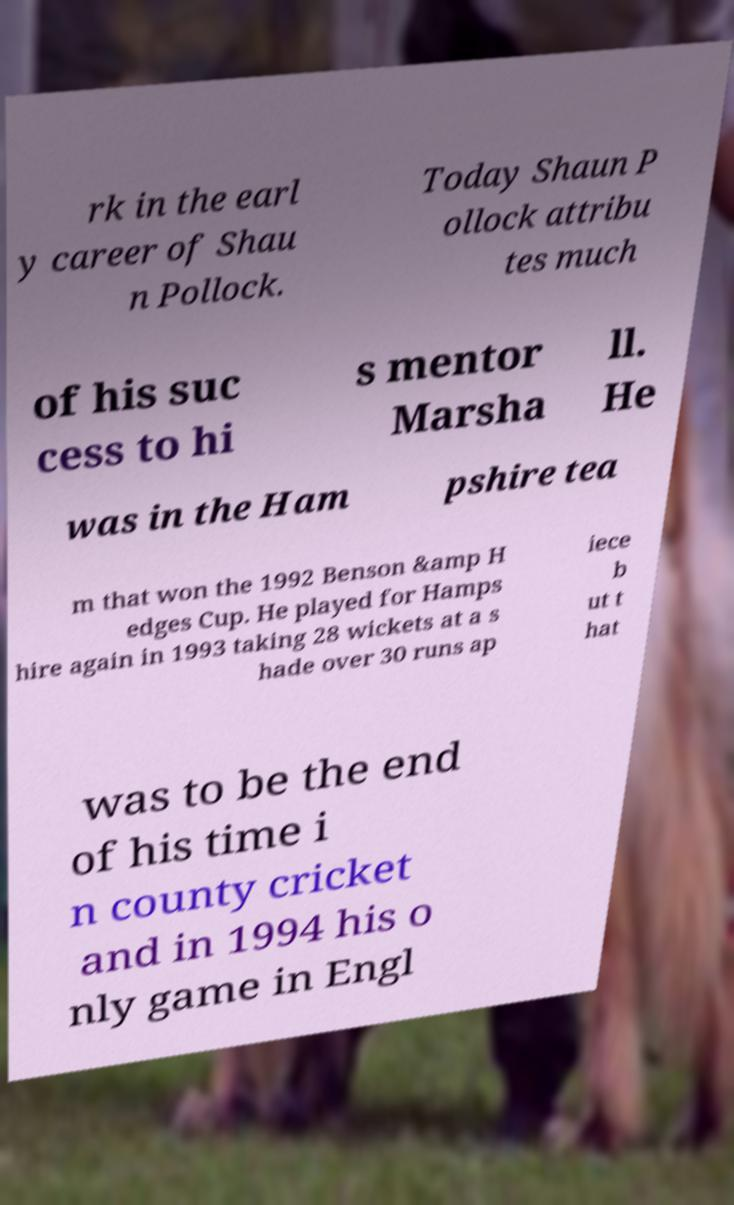Please read and relay the text visible in this image. What does it say? rk in the earl y career of Shau n Pollock. Today Shaun P ollock attribu tes much of his suc cess to hi s mentor Marsha ll. He was in the Ham pshire tea m that won the 1992 Benson &amp H edges Cup. He played for Hamps hire again in 1993 taking 28 wickets at a s hade over 30 runs ap iece b ut t hat was to be the end of his time i n county cricket and in 1994 his o nly game in Engl 